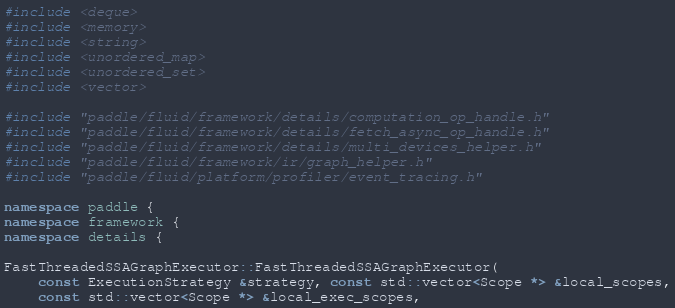<code> <loc_0><loc_0><loc_500><loc_500><_C++_>
#include <deque>
#include <memory>
#include <string>
#include <unordered_map>
#include <unordered_set>
#include <vector>

#include "paddle/fluid/framework/details/computation_op_handle.h"
#include "paddle/fluid/framework/details/fetch_async_op_handle.h"
#include "paddle/fluid/framework/details/multi_devices_helper.h"
#include "paddle/fluid/framework/ir/graph_helper.h"
#include "paddle/fluid/platform/profiler/event_tracing.h"

namespace paddle {
namespace framework {
namespace details {

FastThreadedSSAGraphExecutor::FastThreadedSSAGraphExecutor(
    const ExecutionStrategy &strategy, const std::vector<Scope *> &local_scopes,
    const std::vector<Scope *> &local_exec_scopes,</code> 